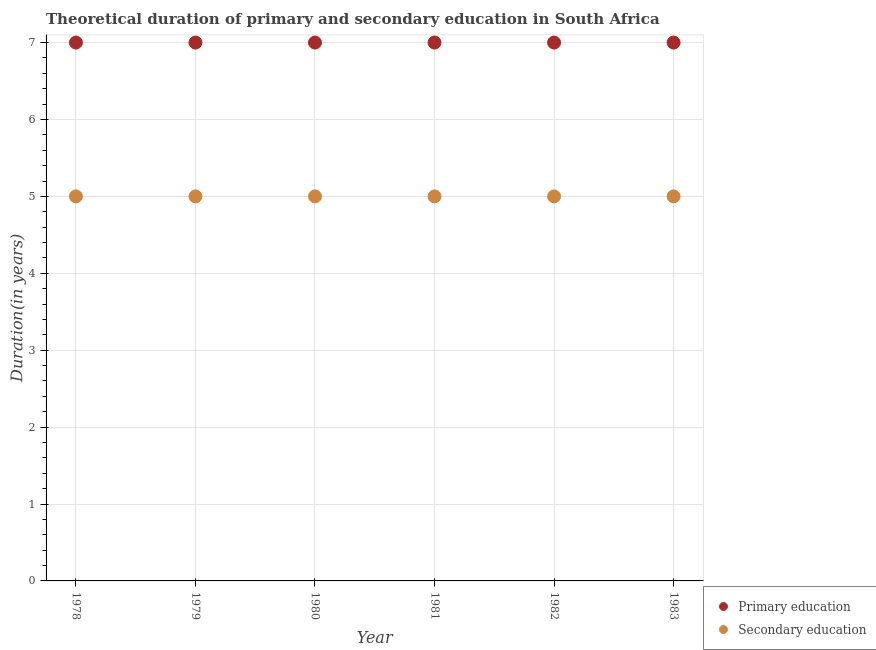What is the duration of primary education in 1981?
Give a very brief answer. 7. Across all years, what is the maximum duration of secondary education?
Make the answer very short. 5. Across all years, what is the minimum duration of primary education?
Your response must be concise. 7. In which year was the duration of secondary education maximum?
Your answer should be very brief. 1978. In which year was the duration of primary education minimum?
Give a very brief answer. 1978. What is the total duration of primary education in the graph?
Provide a short and direct response. 42. What is the difference between the duration of primary education in 1980 and that in 1981?
Give a very brief answer. 0. What is the difference between the duration of primary education in 1982 and the duration of secondary education in 1979?
Make the answer very short. 2. In the year 1980, what is the difference between the duration of secondary education and duration of primary education?
Your answer should be compact. -2. In how many years, is the duration of secondary education greater than 4.8 years?
Offer a terse response. 6. What is the ratio of the duration of primary education in 1978 to that in 1980?
Provide a short and direct response. 1. Is the duration of primary education in 1981 less than that in 1983?
Provide a short and direct response. No. Is the difference between the duration of primary education in 1982 and 1983 greater than the difference between the duration of secondary education in 1982 and 1983?
Offer a very short reply. No. What is the difference between the highest and the lowest duration of primary education?
Provide a short and direct response. 0. Is the sum of the duration of secondary education in 1978 and 1982 greater than the maximum duration of primary education across all years?
Offer a terse response. Yes. Does the duration of primary education monotonically increase over the years?
Provide a short and direct response. No. Is the duration of primary education strictly greater than the duration of secondary education over the years?
Keep it short and to the point. Yes. How many dotlines are there?
Your answer should be compact. 2. How many years are there in the graph?
Your answer should be compact. 6. Does the graph contain grids?
Your answer should be very brief. Yes. How many legend labels are there?
Keep it short and to the point. 2. What is the title of the graph?
Keep it short and to the point. Theoretical duration of primary and secondary education in South Africa. What is the label or title of the X-axis?
Provide a succinct answer. Year. What is the label or title of the Y-axis?
Give a very brief answer. Duration(in years). What is the Duration(in years) in Primary education in 1978?
Make the answer very short. 7. What is the Duration(in years) of Secondary education in 1978?
Keep it short and to the point. 5. What is the Duration(in years) in Secondary education in 1980?
Your answer should be compact. 5. What is the Duration(in years) of Secondary education in 1981?
Offer a terse response. 5. Across all years, what is the maximum Duration(in years) of Primary education?
Ensure brevity in your answer.  7. Across all years, what is the maximum Duration(in years) in Secondary education?
Your answer should be compact. 5. Across all years, what is the minimum Duration(in years) in Secondary education?
Offer a very short reply. 5. What is the total Duration(in years) of Secondary education in the graph?
Ensure brevity in your answer.  30. What is the difference between the Duration(in years) in Primary education in 1978 and that in 1979?
Offer a terse response. 0. What is the difference between the Duration(in years) in Primary education in 1978 and that in 1980?
Offer a terse response. 0. What is the difference between the Duration(in years) in Secondary education in 1978 and that in 1981?
Give a very brief answer. 0. What is the difference between the Duration(in years) in Secondary education in 1978 and that in 1982?
Provide a short and direct response. 0. What is the difference between the Duration(in years) in Primary education in 1979 and that in 1980?
Your response must be concise. 0. What is the difference between the Duration(in years) of Secondary education in 1979 and that in 1980?
Provide a succinct answer. 0. What is the difference between the Duration(in years) of Primary education in 1979 and that in 1982?
Offer a terse response. 0. What is the difference between the Duration(in years) of Secondary education in 1979 and that in 1982?
Provide a short and direct response. 0. What is the difference between the Duration(in years) of Primary education in 1979 and that in 1983?
Offer a very short reply. 0. What is the difference between the Duration(in years) of Primary education in 1980 and that in 1981?
Ensure brevity in your answer.  0. What is the difference between the Duration(in years) of Primary education in 1980 and that in 1982?
Your answer should be very brief. 0. What is the difference between the Duration(in years) in Secondary education in 1980 and that in 1982?
Keep it short and to the point. 0. What is the difference between the Duration(in years) in Primary education in 1981 and that in 1982?
Make the answer very short. 0. What is the difference between the Duration(in years) in Primary education in 1978 and the Duration(in years) in Secondary education in 1979?
Your response must be concise. 2. What is the difference between the Duration(in years) in Primary education in 1978 and the Duration(in years) in Secondary education in 1980?
Offer a very short reply. 2. What is the difference between the Duration(in years) in Primary education in 1978 and the Duration(in years) in Secondary education in 1982?
Give a very brief answer. 2. What is the difference between the Duration(in years) of Primary education in 1979 and the Duration(in years) of Secondary education in 1980?
Your answer should be very brief. 2. What is the difference between the Duration(in years) of Primary education in 1979 and the Duration(in years) of Secondary education in 1982?
Keep it short and to the point. 2. What is the difference between the Duration(in years) in Primary education in 1980 and the Duration(in years) in Secondary education in 1983?
Offer a terse response. 2. What is the difference between the Duration(in years) of Primary education in 1981 and the Duration(in years) of Secondary education in 1982?
Ensure brevity in your answer.  2. What is the difference between the Duration(in years) of Primary education in 1981 and the Duration(in years) of Secondary education in 1983?
Your answer should be compact. 2. What is the difference between the Duration(in years) of Primary education in 1982 and the Duration(in years) of Secondary education in 1983?
Your answer should be compact. 2. What is the average Duration(in years) of Secondary education per year?
Give a very brief answer. 5. In the year 1981, what is the difference between the Duration(in years) in Primary education and Duration(in years) in Secondary education?
Your answer should be very brief. 2. In the year 1982, what is the difference between the Duration(in years) of Primary education and Duration(in years) of Secondary education?
Give a very brief answer. 2. What is the ratio of the Duration(in years) of Secondary education in 1978 to that in 1979?
Your answer should be very brief. 1. What is the ratio of the Duration(in years) in Secondary education in 1978 to that in 1981?
Provide a succinct answer. 1. What is the ratio of the Duration(in years) of Primary education in 1978 to that in 1982?
Your answer should be very brief. 1. What is the ratio of the Duration(in years) in Secondary education in 1978 to that in 1982?
Make the answer very short. 1. What is the ratio of the Duration(in years) of Primary education in 1978 to that in 1983?
Your response must be concise. 1. What is the ratio of the Duration(in years) in Primary education in 1979 to that in 1980?
Keep it short and to the point. 1. What is the ratio of the Duration(in years) in Secondary education in 1979 to that in 1980?
Your answer should be very brief. 1. What is the ratio of the Duration(in years) in Primary education in 1979 to that in 1981?
Your answer should be very brief. 1. What is the ratio of the Duration(in years) of Secondary education in 1979 to that in 1981?
Provide a succinct answer. 1. What is the ratio of the Duration(in years) of Secondary education in 1979 to that in 1983?
Make the answer very short. 1. What is the ratio of the Duration(in years) of Secondary education in 1980 to that in 1981?
Give a very brief answer. 1. What is the ratio of the Duration(in years) in Secondary education in 1980 to that in 1982?
Your response must be concise. 1. What is the ratio of the Duration(in years) in Primary education in 1981 to that in 1982?
Give a very brief answer. 1. What is the ratio of the Duration(in years) in Primary education in 1981 to that in 1983?
Provide a short and direct response. 1. What is the ratio of the Duration(in years) of Secondary education in 1982 to that in 1983?
Give a very brief answer. 1. What is the difference between the highest and the lowest Duration(in years) of Secondary education?
Your answer should be compact. 0. 